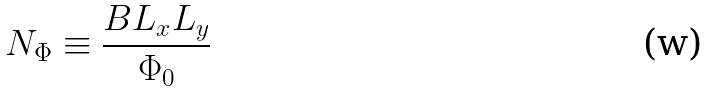Convert formula to latex. <formula><loc_0><loc_0><loc_500><loc_500>N _ { \Phi } \equiv \frac { B L _ { x } L _ { y } } { \Phi _ { 0 } }</formula> 